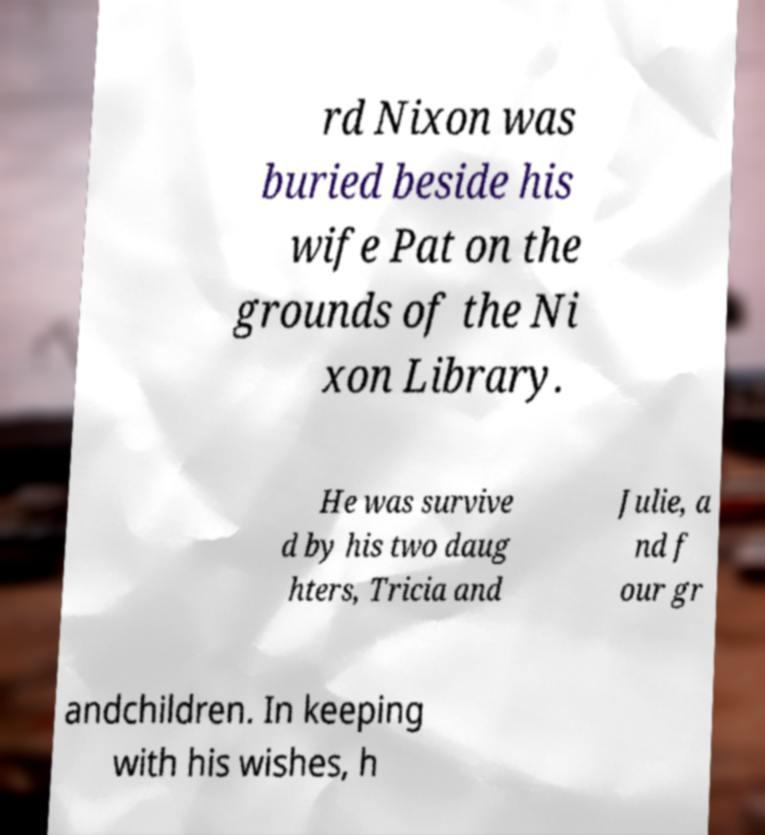Please identify and transcribe the text found in this image. rd Nixon was buried beside his wife Pat on the grounds of the Ni xon Library. He was survive d by his two daug hters, Tricia and Julie, a nd f our gr andchildren. In keeping with his wishes, h 